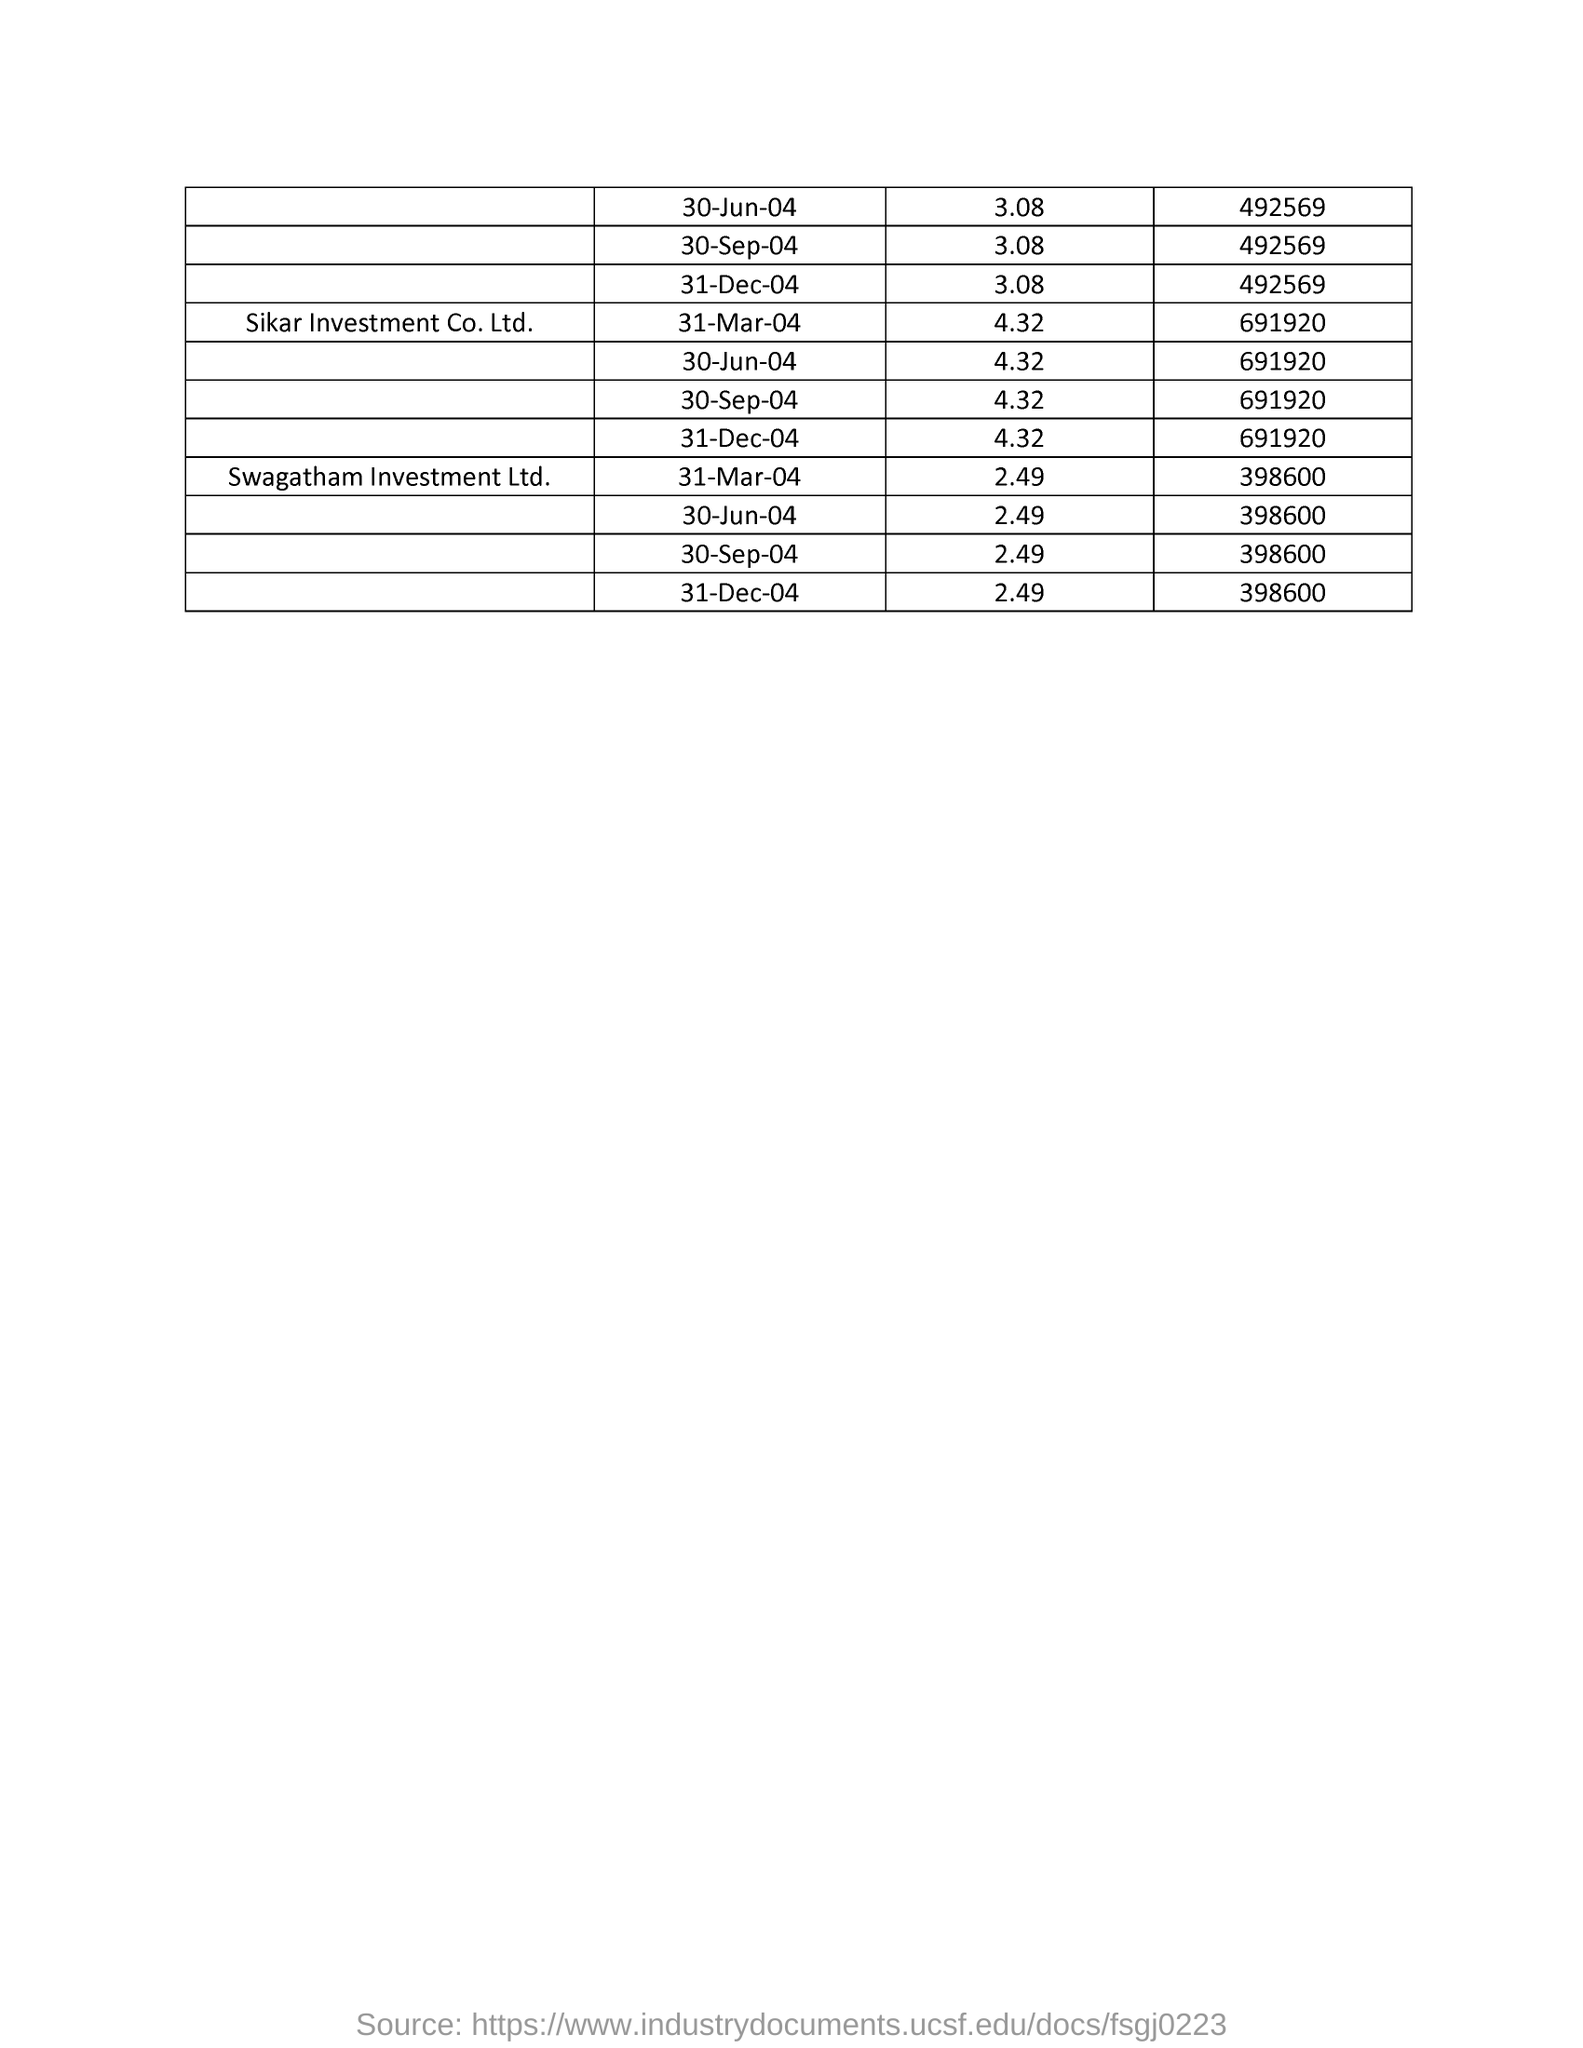List a handful of essential elements in this visual. The first company in the list is Sikar Investment Co. Ltd. 